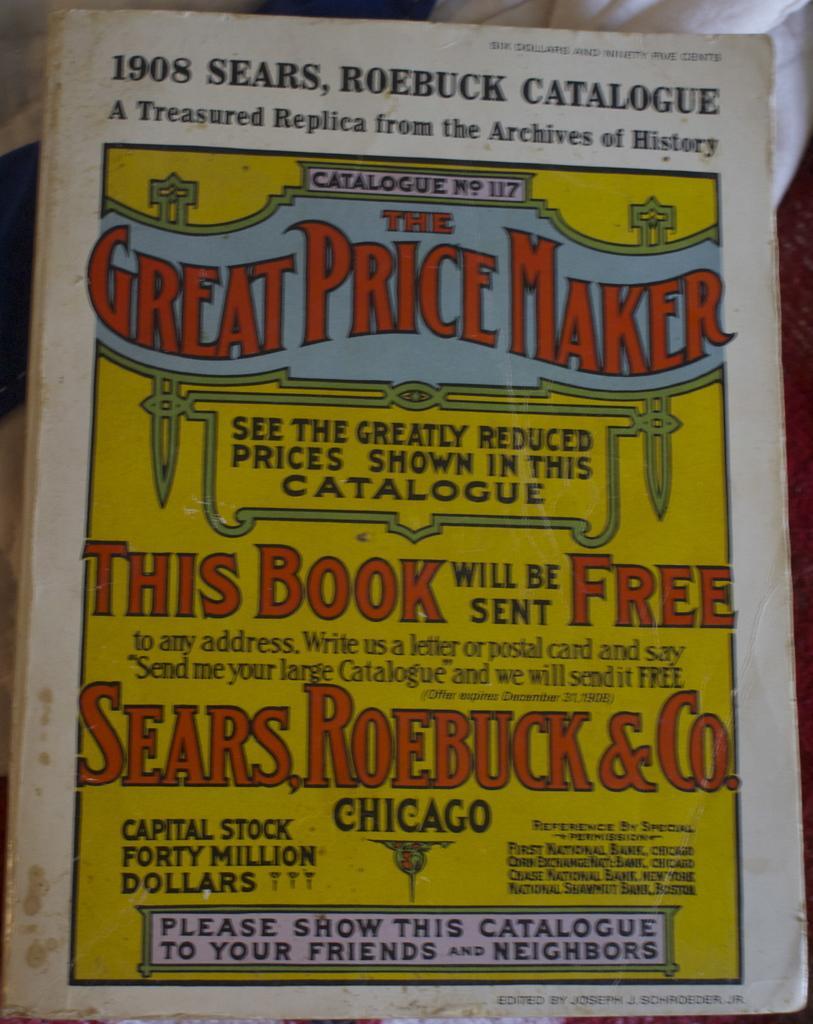Can you describe this image briefly? In this image we can see a book with some printed text on it which is placed on the surface. 